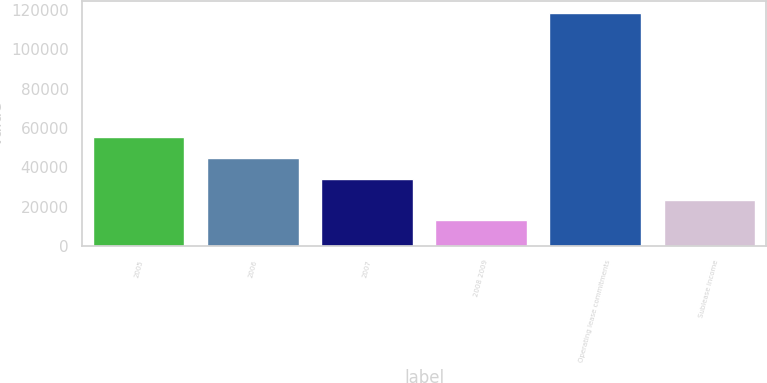Convert chart to OTSL. <chart><loc_0><loc_0><loc_500><loc_500><bar_chart><fcel>2005<fcel>2006<fcel>2007<fcel>2008 2009<fcel>Operating lease commitments<fcel>Sublease income<nl><fcel>55201.2<fcel>44662.4<fcel>34123.6<fcel>13046<fcel>118434<fcel>23584.8<nl></chart> 